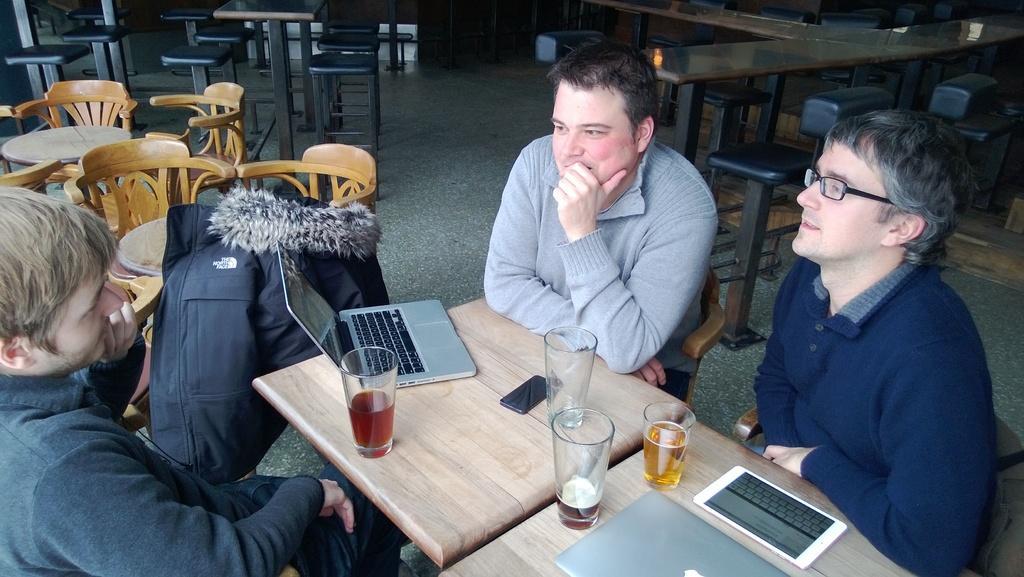Please provide a concise description of this image. In this picture we can see benches and stools on the floor. We can see men sitting on the chairs. On the tables we can see glasses with drinks, a mobile, an empty glass and laptops. This is a jacket in black color. 